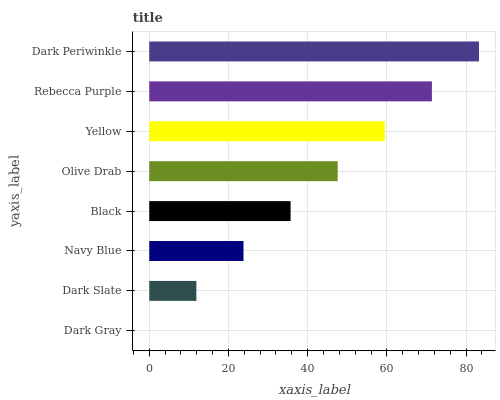Is Dark Gray the minimum?
Answer yes or no. Yes. Is Dark Periwinkle the maximum?
Answer yes or no. Yes. Is Dark Slate the minimum?
Answer yes or no. No. Is Dark Slate the maximum?
Answer yes or no. No. Is Dark Slate greater than Dark Gray?
Answer yes or no. Yes. Is Dark Gray less than Dark Slate?
Answer yes or no. Yes. Is Dark Gray greater than Dark Slate?
Answer yes or no. No. Is Dark Slate less than Dark Gray?
Answer yes or no. No. Is Olive Drab the high median?
Answer yes or no. Yes. Is Black the low median?
Answer yes or no. Yes. Is Navy Blue the high median?
Answer yes or no. No. Is Dark Periwinkle the low median?
Answer yes or no. No. 